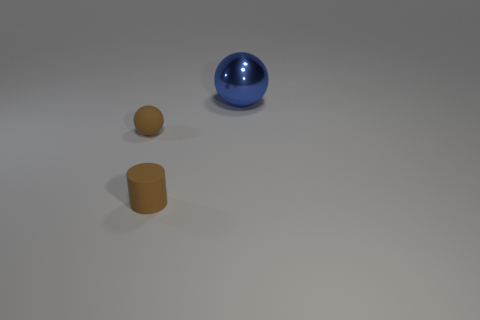Add 2 blue objects. How many objects exist? 5 Subtract all spheres. How many objects are left? 1 Subtract 1 brown cylinders. How many objects are left? 2 Subtract all small brown matte cylinders. Subtract all rubber things. How many objects are left? 0 Add 1 small spheres. How many small spheres are left? 2 Add 3 balls. How many balls exist? 5 